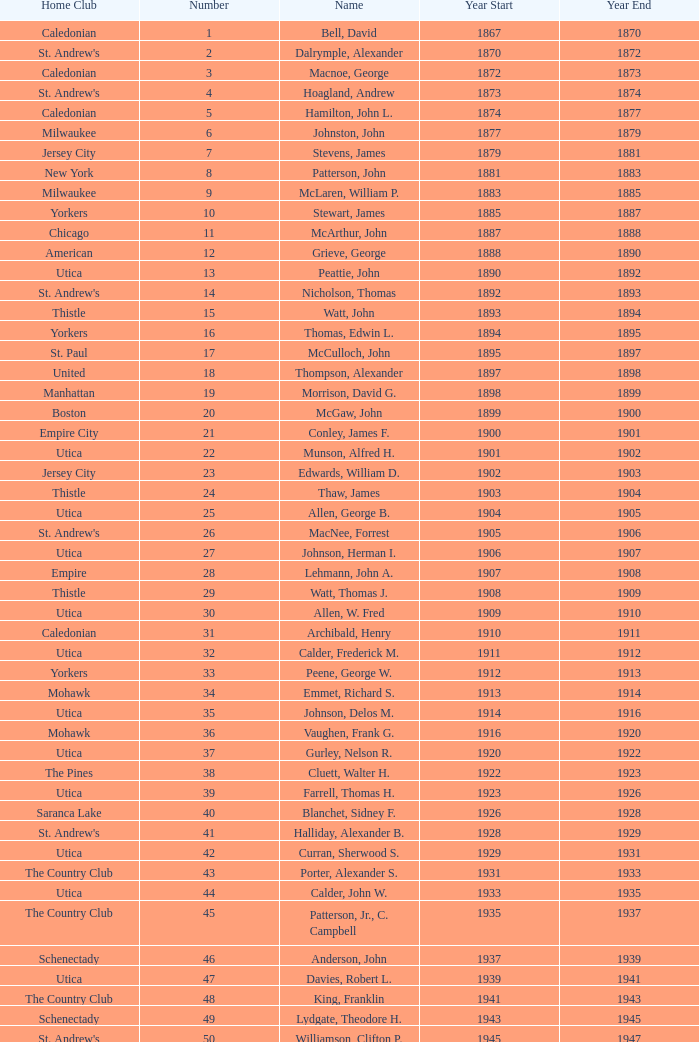Which Number has a Name of cooper, c. kenneth, and a Year End larger than 1984? None. 